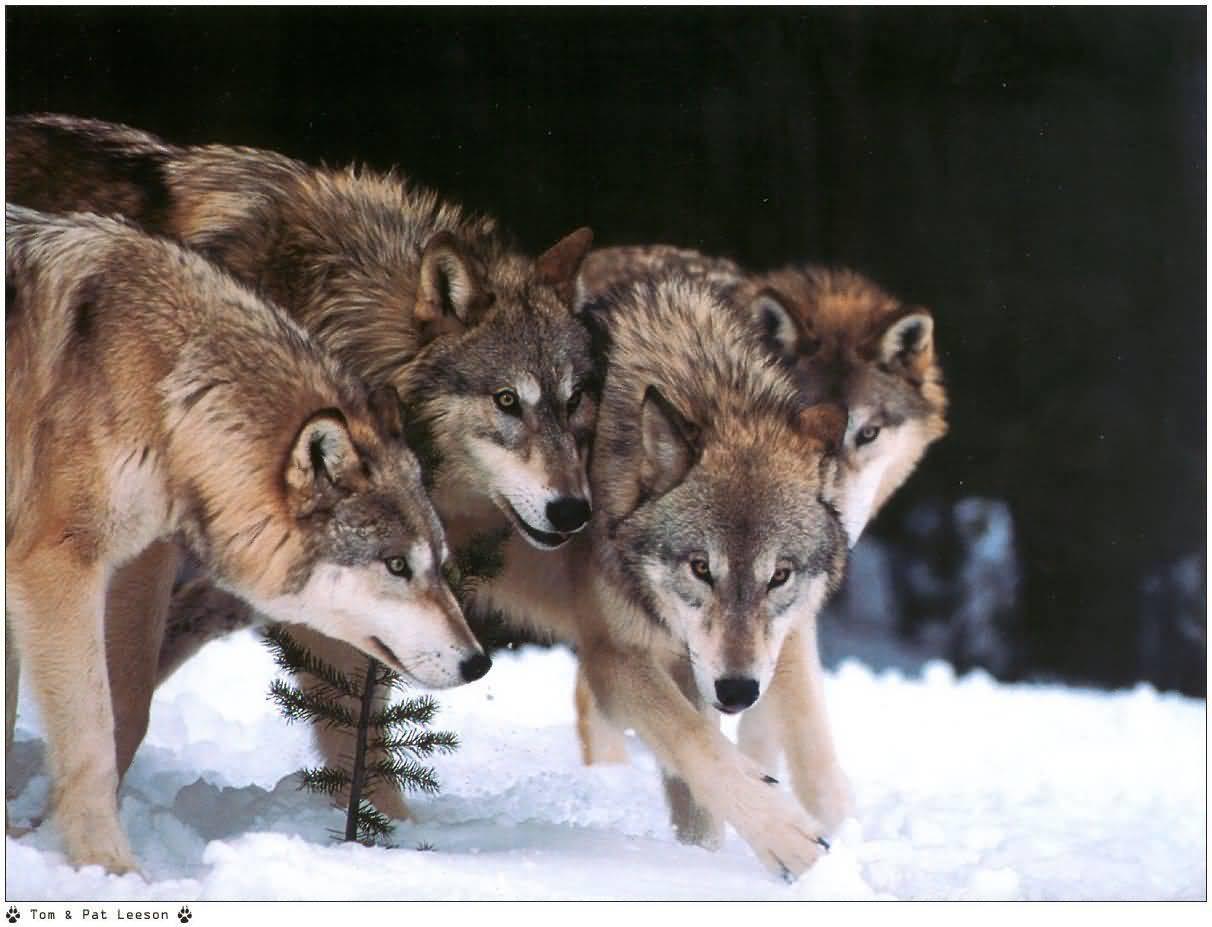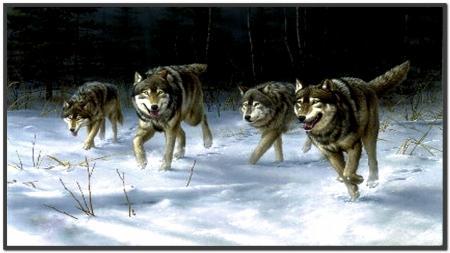The first image is the image on the left, the second image is the image on the right. Analyze the images presented: Is the assertion "An image shows exactly three wolves, including one black one, running in a rightward direction." valid? Answer yes or no. No. The first image is the image on the left, the second image is the image on the right. Evaluate the accuracy of this statement regarding the images: "There is at least one wolf that is completely black.". Is it true? Answer yes or no. No. 